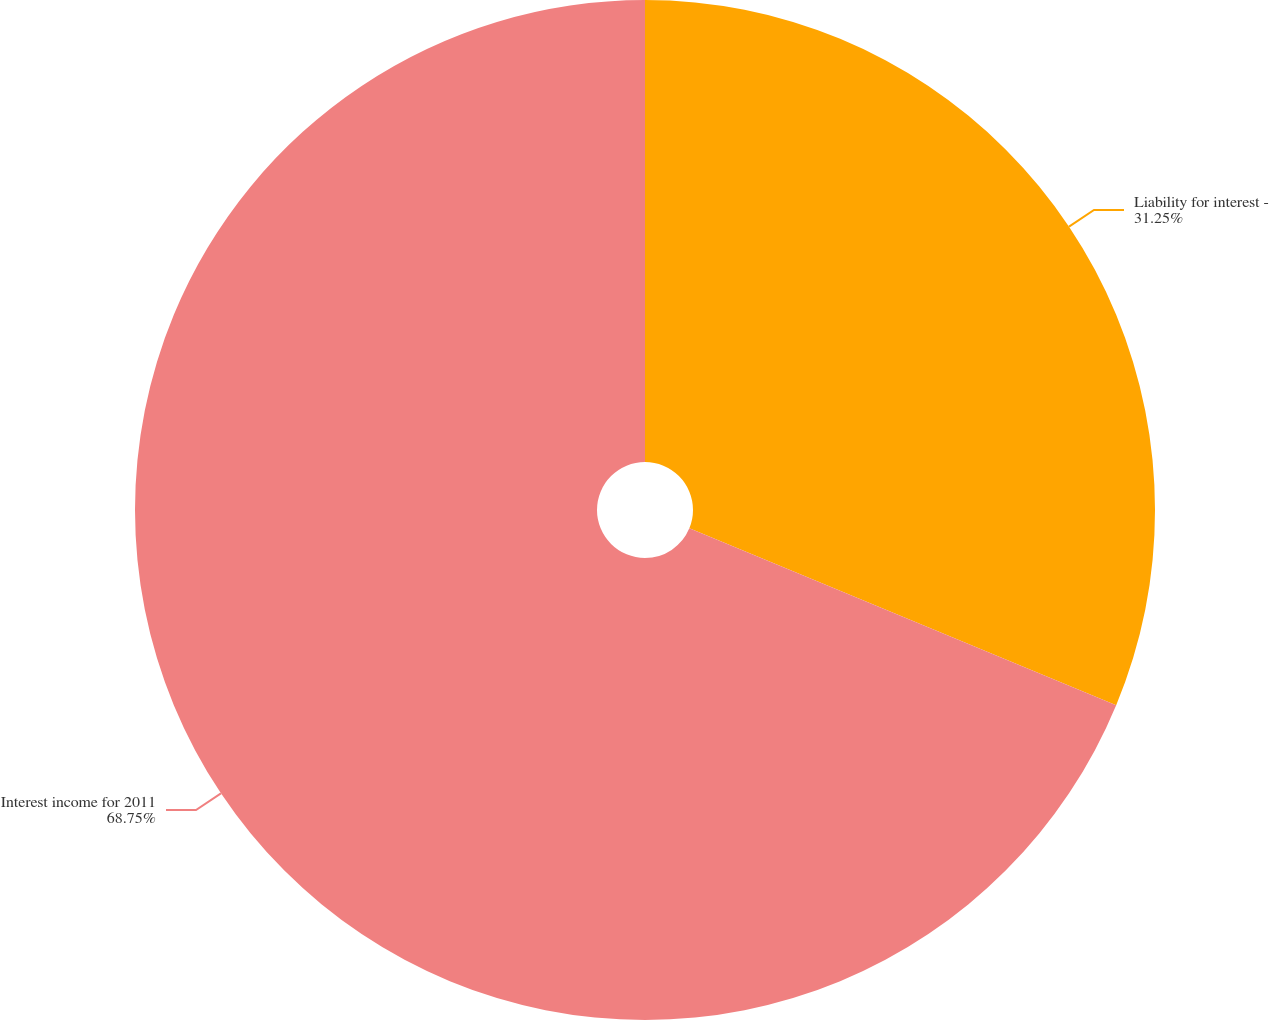Convert chart to OTSL. <chart><loc_0><loc_0><loc_500><loc_500><pie_chart><fcel>Liability for interest -<fcel>Interest income for 2011<nl><fcel>31.25%<fcel>68.75%<nl></chart> 